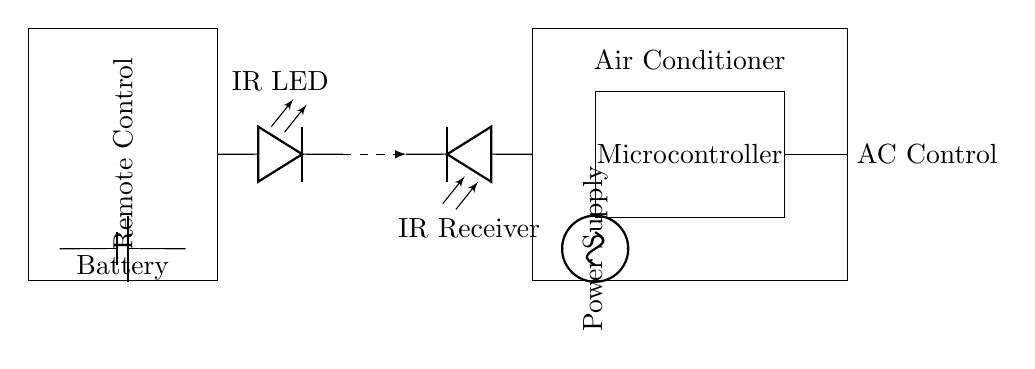What component is used to transmit signals to the air conditioner? The IR LED is the component used for transmitting infrared signals from the remote control to the air conditioner. It is marked clearly in the circuit diagram.
Answer: IR LED What is the main function of the microcontroller in this circuit? The microcontroller processes the signals received by the IR receiver and controls the operation of the air conditioner accordingly. It interprets the signals and sends commands to the AC Control component.
Answer: Control How does the signal travel from the remote to the air conditioner? The signal travels wirelessly as an infrared light from the IR LED to the IR Receiver, which converts it into electrical signals that the microcontroller understands. This connection is represented as a dashed line in the diagram.
Answer: Wirelessly What is the purpose of the power supply in the air conditioner circuit? The power supply provides the necessary voltage and current to the microcontroller and other components of the air conditioner, allowing them to function properly. It is shown at the bottom part of the AC unit.
Answer: Power What type of diode is used in the circuit? A photodiode is used in the circuit, which functions as the IR receiver to convert the incoming infrared light signals into electrical signals. This is indicated next to the IR Receiver in the diagram.
Answer: Photodiode What type of battery is indicated in the remote control circuit? The battery is a standard battery type, represented in the circuit as a simple battery symbol providing power to the remote control. It's located in the lower section of the remote control box.
Answer: Battery What is the connection type between the IR LED and the IR Receiver? The connection is represented by a dashed line, indicating a wireless signal transmission between the IR LED in the remote control and the IR Receiver in the air conditioner.
Answer: Wireless 